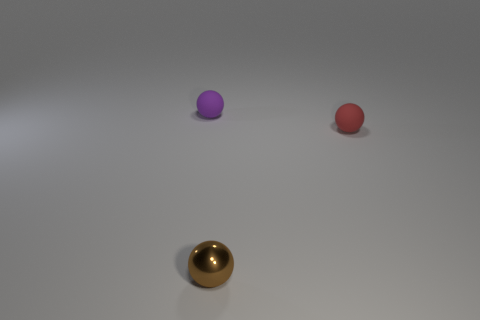Add 3 purple spheres. How many objects exist? 6 Subtract all purple balls. How many balls are left? 2 Subtract all small red matte things. Subtract all tiny brown shiny objects. How many objects are left? 1 Add 2 tiny brown metallic objects. How many tiny brown metallic objects are left? 3 Add 2 tiny red metallic things. How many tiny red metallic things exist? 2 Subtract 0 cyan cubes. How many objects are left? 3 Subtract 1 spheres. How many spheres are left? 2 Subtract all cyan balls. Subtract all green cubes. How many balls are left? 3 Subtract all brown blocks. How many purple spheres are left? 1 